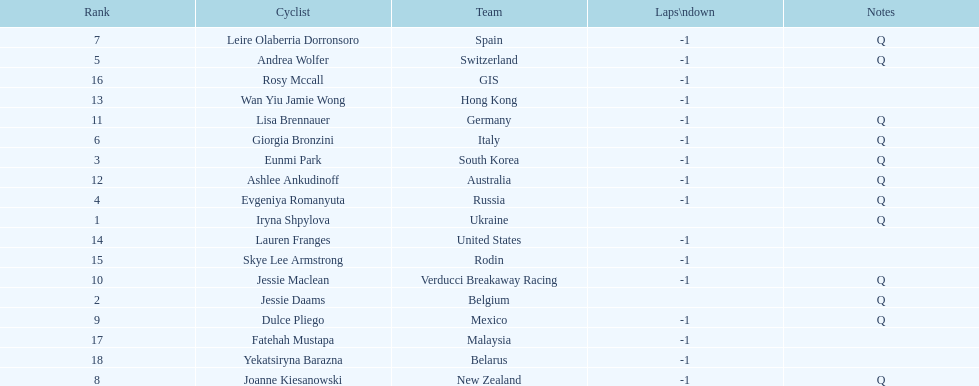Who is the last cyclist listed? Yekatsiryna Barazna. 